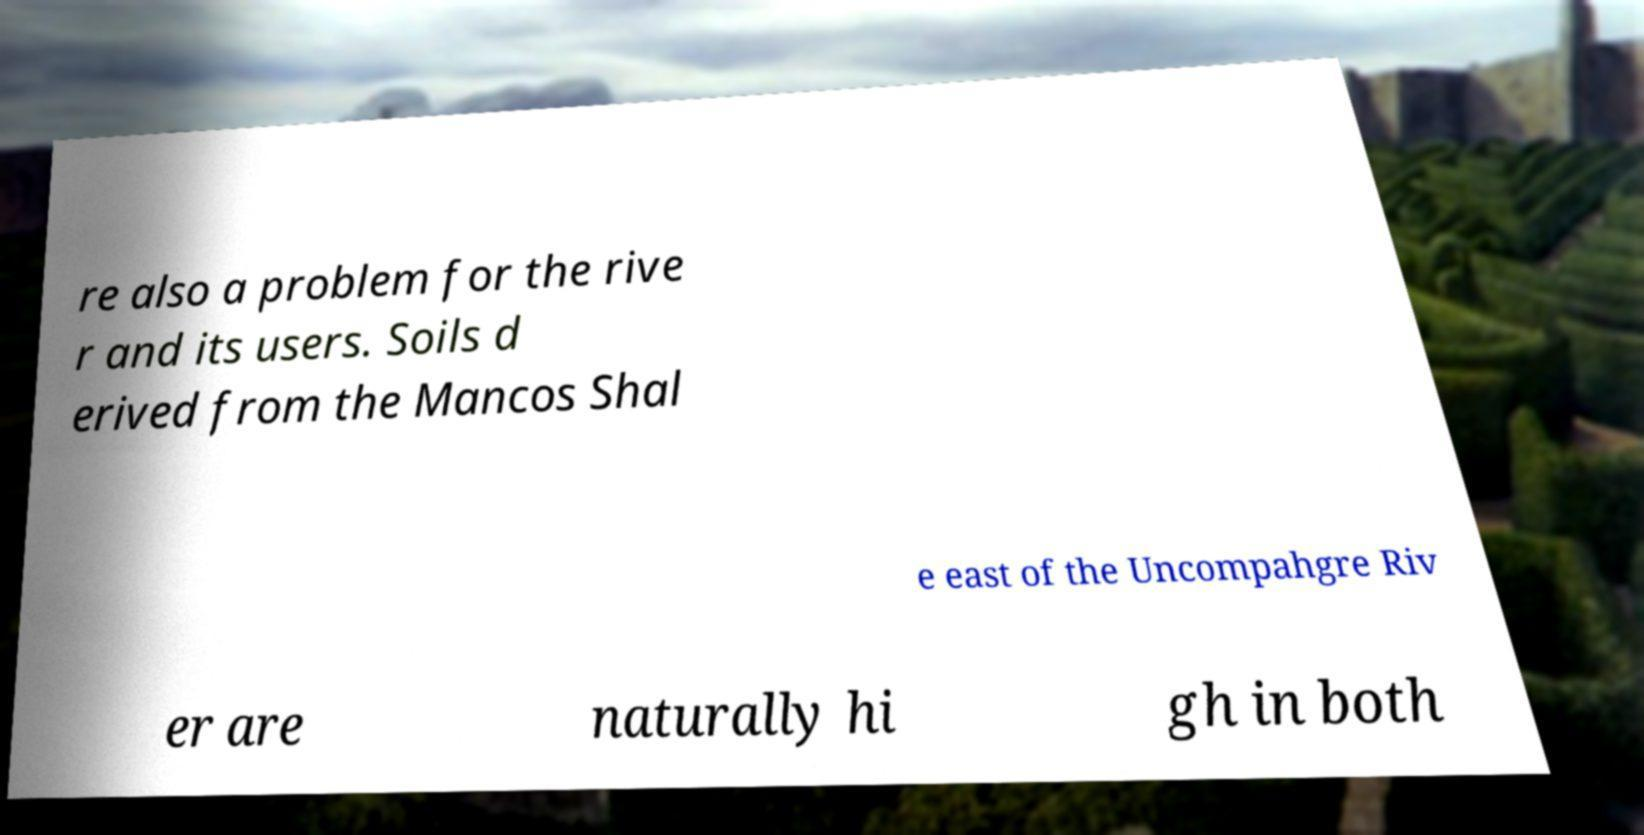Could you assist in decoding the text presented in this image and type it out clearly? re also a problem for the rive r and its users. Soils d erived from the Mancos Shal e east of the Uncompahgre Riv er are naturally hi gh in both 